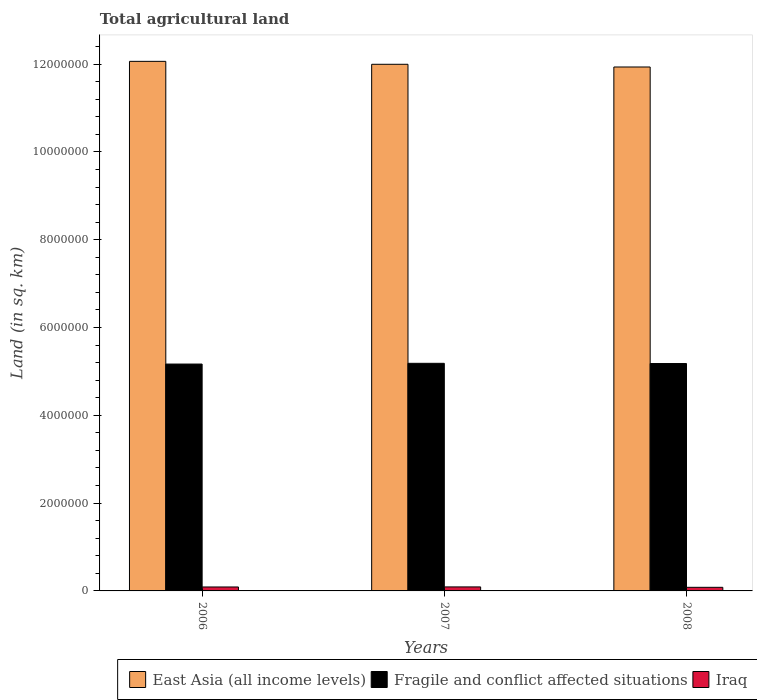How many different coloured bars are there?
Ensure brevity in your answer.  3. How many groups of bars are there?
Your answer should be very brief. 3. Are the number of bars per tick equal to the number of legend labels?
Your answer should be very brief. Yes. Are the number of bars on each tick of the X-axis equal?
Offer a very short reply. Yes. How many bars are there on the 3rd tick from the left?
Your response must be concise. 3. What is the total agricultural land in East Asia (all income levels) in 2006?
Make the answer very short. 1.21e+07. Across all years, what is the maximum total agricultural land in Fragile and conflict affected situations?
Ensure brevity in your answer.  5.18e+06. Across all years, what is the minimum total agricultural land in Fragile and conflict affected situations?
Keep it short and to the point. 5.17e+06. What is the total total agricultural land in Fragile and conflict affected situations in the graph?
Your answer should be compact. 1.55e+07. What is the difference between the total agricultural land in Fragile and conflict affected situations in 2006 and that in 2008?
Make the answer very short. -1.16e+04. What is the difference between the total agricultural land in Fragile and conflict affected situations in 2007 and the total agricultural land in Iraq in 2006?
Make the answer very short. 5.09e+06. What is the average total agricultural land in Iraq per year?
Your answer should be compact. 8.77e+04. In the year 2007, what is the difference between the total agricultural land in Iraq and total agricultural land in Fragile and conflict affected situations?
Your answer should be very brief. -5.09e+06. In how many years, is the total agricultural land in East Asia (all income levels) greater than 10400000 sq.km?
Offer a very short reply. 3. What is the ratio of the total agricultural land in East Asia (all income levels) in 2007 to that in 2008?
Provide a succinct answer. 1.01. Is the total agricultural land in East Asia (all income levels) in 2007 less than that in 2008?
Offer a very short reply. No. What is the difference between the highest and the second highest total agricultural land in Fragile and conflict affected situations?
Provide a short and direct response. 5148.9. What is the difference between the highest and the lowest total agricultural land in East Asia (all income levels)?
Your answer should be compact. 1.28e+05. In how many years, is the total agricultural land in East Asia (all income levels) greater than the average total agricultural land in East Asia (all income levels) taken over all years?
Your response must be concise. 1. What does the 1st bar from the left in 2006 represents?
Your answer should be compact. East Asia (all income levels). What does the 3rd bar from the right in 2006 represents?
Your response must be concise. East Asia (all income levels). Are the values on the major ticks of Y-axis written in scientific E-notation?
Offer a very short reply. No. Does the graph contain any zero values?
Keep it short and to the point. No. Does the graph contain grids?
Your response must be concise. No. How are the legend labels stacked?
Provide a succinct answer. Horizontal. What is the title of the graph?
Make the answer very short. Total agricultural land. What is the label or title of the Y-axis?
Keep it short and to the point. Land (in sq. km). What is the Land (in sq. km) in East Asia (all income levels) in 2006?
Provide a succinct answer. 1.21e+07. What is the Land (in sq. km) of Fragile and conflict affected situations in 2006?
Your response must be concise. 5.17e+06. What is the Land (in sq. km) of Iraq in 2006?
Keep it short and to the point. 8.99e+04. What is the Land (in sq. km) of East Asia (all income levels) in 2007?
Keep it short and to the point. 1.20e+07. What is the Land (in sq. km) of Fragile and conflict affected situations in 2007?
Your answer should be compact. 5.18e+06. What is the Land (in sq. km) in Iraq in 2007?
Offer a very short reply. 9.14e+04. What is the Land (in sq. km) in East Asia (all income levels) in 2008?
Your response must be concise. 1.19e+07. What is the Land (in sq. km) of Fragile and conflict affected situations in 2008?
Provide a succinct answer. 5.18e+06. What is the Land (in sq. km) of Iraq in 2008?
Your answer should be very brief. 8.19e+04. Across all years, what is the maximum Land (in sq. km) of East Asia (all income levels)?
Ensure brevity in your answer.  1.21e+07. Across all years, what is the maximum Land (in sq. km) of Fragile and conflict affected situations?
Give a very brief answer. 5.18e+06. Across all years, what is the maximum Land (in sq. km) in Iraq?
Your response must be concise. 9.14e+04. Across all years, what is the minimum Land (in sq. km) of East Asia (all income levels)?
Provide a succinct answer. 1.19e+07. Across all years, what is the minimum Land (in sq. km) of Fragile and conflict affected situations?
Make the answer very short. 5.17e+06. Across all years, what is the minimum Land (in sq. km) of Iraq?
Give a very brief answer. 8.19e+04. What is the total Land (in sq. km) of East Asia (all income levels) in the graph?
Your response must be concise. 3.60e+07. What is the total Land (in sq. km) in Fragile and conflict affected situations in the graph?
Keep it short and to the point. 1.55e+07. What is the total Land (in sq. km) in Iraq in the graph?
Your response must be concise. 2.63e+05. What is the difference between the Land (in sq. km) in East Asia (all income levels) in 2006 and that in 2007?
Make the answer very short. 6.70e+04. What is the difference between the Land (in sq. km) of Fragile and conflict affected situations in 2006 and that in 2007?
Offer a terse response. -1.68e+04. What is the difference between the Land (in sq. km) in Iraq in 2006 and that in 2007?
Your answer should be very brief. -1500. What is the difference between the Land (in sq. km) in East Asia (all income levels) in 2006 and that in 2008?
Offer a very short reply. 1.28e+05. What is the difference between the Land (in sq. km) in Fragile and conflict affected situations in 2006 and that in 2008?
Make the answer very short. -1.16e+04. What is the difference between the Land (in sq. km) in Iraq in 2006 and that in 2008?
Your response must be concise. 8000. What is the difference between the Land (in sq. km) in East Asia (all income levels) in 2007 and that in 2008?
Give a very brief answer. 6.14e+04. What is the difference between the Land (in sq. km) in Fragile and conflict affected situations in 2007 and that in 2008?
Offer a very short reply. 5148.9. What is the difference between the Land (in sq. km) of Iraq in 2007 and that in 2008?
Your response must be concise. 9500. What is the difference between the Land (in sq. km) of East Asia (all income levels) in 2006 and the Land (in sq. km) of Fragile and conflict affected situations in 2007?
Offer a terse response. 6.88e+06. What is the difference between the Land (in sq. km) in East Asia (all income levels) in 2006 and the Land (in sq. km) in Iraq in 2007?
Give a very brief answer. 1.20e+07. What is the difference between the Land (in sq. km) of Fragile and conflict affected situations in 2006 and the Land (in sq. km) of Iraq in 2007?
Your response must be concise. 5.08e+06. What is the difference between the Land (in sq. km) of East Asia (all income levels) in 2006 and the Land (in sq. km) of Fragile and conflict affected situations in 2008?
Keep it short and to the point. 6.88e+06. What is the difference between the Land (in sq. km) of East Asia (all income levels) in 2006 and the Land (in sq. km) of Iraq in 2008?
Provide a succinct answer. 1.20e+07. What is the difference between the Land (in sq. km) in Fragile and conflict affected situations in 2006 and the Land (in sq. km) in Iraq in 2008?
Your answer should be compact. 5.09e+06. What is the difference between the Land (in sq. km) in East Asia (all income levels) in 2007 and the Land (in sq. km) in Fragile and conflict affected situations in 2008?
Give a very brief answer. 6.82e+06. What is the difference between the Land (in sq. km) in East Asia (all income levels) in 2007 and the Land (in sq. km) in Iraq in 2008?
Provide a succinct answer. 1.19e+07. What is the difference between the Land (in sq. km) in Fragile and conflict affected situations in 2007 and the Land (in sq. km) in Iraq in 2008?
Your answer should be very brief. 5.10e+06. What is the average Land (in sq. km) in East Asia (all income levels) per year?
Offer a terse response. 1.20e+07. What is the average Land (in sq. km) in Fragile and conflict affected situations per year?
Keep it short and to the point. 5.18e+06. What is the average Land (in sq. km) in Iraq per year?
Ensure brevity in your answer.  8.77e+04. In the year 2006, what is the difference between the Land (in sq. km) in East Asia (all income levels) and Land (in sq. km) in Fragile and conflict affected situations?
Your answer should be very brief. 6.90e+06. In the year 2006, what is the difference between the Land (in sq. km) in East Asia (all income levels) and Land (in sq. km) in Iraq?
Provide a succinct answer. 1.20e+07. In the year 2006, what is the difference between the Land (in sq. km) in Fragile and conflict affected situations and Land (in sq. km) in Iraq?
Ensure brevity in your answer.  5.08e+06. In the year 2007, what is the difference between the Land (in sq. km) of East Asia (all income levels) and Land (in sq. km) of Fragile and conflict affected situations?
Keep it short and to the point. 6.81e+06. In the year 2007, what is the difference between the Land (in sq. km) in East Asia (all income levels) and Land (in sq. km) in Iraq?
Provide a short and direct response. 1.19e+07. In the year 2007, what is the difference between the Land (in sq. km) of Fragile and conflict affected situations and Land (in sq. km) of Iraq?
Offer a terse response. 5.09e+06. In the year 2008, what is the difference between the Land (in sq. km) of East Asia (all income levels) and Land (in sq. km) of Fragile and conflict affected situations?
Provide a succinct answer. 6.75e+06. In the year 2008, what is the difference between the Land (in sq. km) in East Asia (all income levels) and Land (in sq. km) in Iraq?
Your answer should be very brief. 1.19e+07. In the year 2008, what is the difference between the Land (in sq. km) in Fragile and conflict affected situations and Land (in sq. km) in Iraq?
Offer a terse response. 5.10e+06. What is the ratio of the Land (in sq. km) in East Asia (all income levels) in 2006 to that in 2007?
Your answer should be very brief. 1.01. What is the ratio of the Land (in sq. km) in Fragile and conflict affected situations in 2006 to that in 2007?
Ensure brevity in your answer.  1. What is the ratio of the Land (in sq. km) of Iraq in 2006 to that in 2007?
Your response must be concise. 0.98. What is the ratio of the Land (in sq. km) in East Asia (all income levels) in 2006 to that in 2008?
Make the answer very short. 1.01. What is the ratio of the Land (in sq. km) of Iraq in 2006 to that in 2008?
Provide a succinct answer. 1.1. What is the ratio of the Land (in sq. km) in East Asia (all income levels) in 2007 to that in 2008?
Offer a terse response. 1.01. What is the ratio of the Land (in sq. km) in Fragile and conflict affected situations in 2007 to that in 2008?
Give a very brief answer. 1. What is the ratio of the Land (in sq. km) of Iraq in 2007 to that in 2008?
Your answer should be very brief. 1.12. What is the difference between the highest and the second highest Land (in sq. km) of East Asia (all income levels)?
Make the answer very short. 6.70e+04. What is the difference between the highest and the second highest Land (in sq. km) of Fragile and conflict affected situations?
Provide a short and direct response. 5148.9. What is the difference between the highest and the second highest Land (in sq. km) of Iraq?
Your response must be concise. 1500. What is the difference between the highest and the lowest Land (in sq. km) of East Asia (all income levels)?
Your answer should be very brief. 1.28e+05. What is the difference between the highest and the lowest Land (in sq. km) in Fragile and conflict affected situations?
Give a very brief answer. 1.68e+04. What is the difference between the highest and the lowest Land (in sq. km) of Iraq?
Offer a terse response. 9500. 